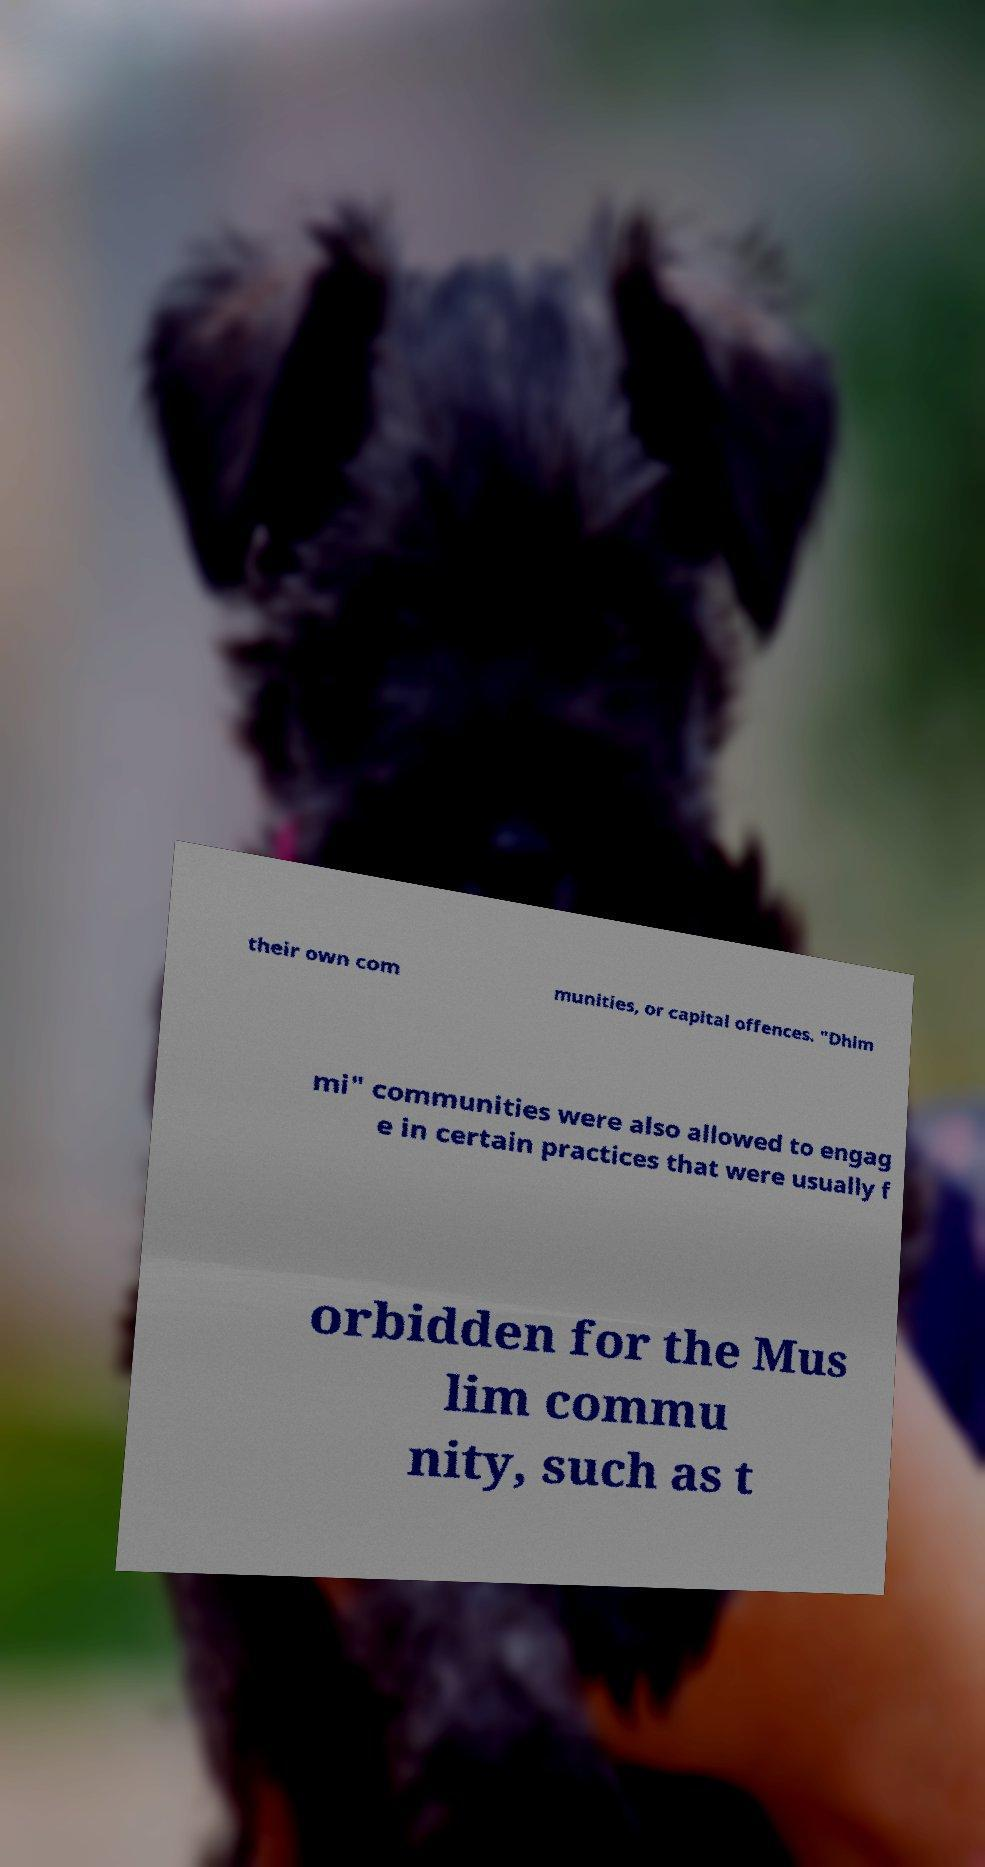Could you extract and type out the text from this image? their own com munities, or capital offences. "Dhim mi" communities were also allowed to engag e in certain practices that were usually f orbidden for the Mus lim commu nity, such as t 